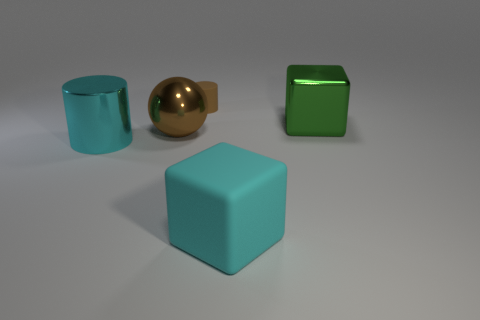There is a object that is in front of the shiny cylinder; what number of large cylinders are in front of it?
Ensure brevity in your answer.  0. How many other objects are the same shape as the small brown matte thing?
Provide a short and direct response. 1. What number of objects are either large gray blocks or cyan objects that are on the right side of the brown metal thing?
Your answer should be very brief. 1. Are there more large green metallic things on the right side of the brown matte object than brown objects that are right of the large green cube?
Offer a terse response. Yes. What is the shape of the metallic object to the right of the rubber thing in front of the brown rubber object that is behind the metal cylinder?
Provide a short and direct response. Cube. What shape is the cyan thing right of the big cyan thing on the left side of the big shiny sphere?
Ensure brevity in your answer.  Cube. Are there any other cubes made of the same material as the big cyan block?
Offer a terse response. No. The cylinder that is the same color as the large matte object is what size?
Offer a very short reply. Large. How many green things are big metallic cylinders or big shiny objects?
Offer a very short reply. 1. Are there any tiny matte cylinders that have the same color as the big rubber object?
Your answer should be very brief. No. 